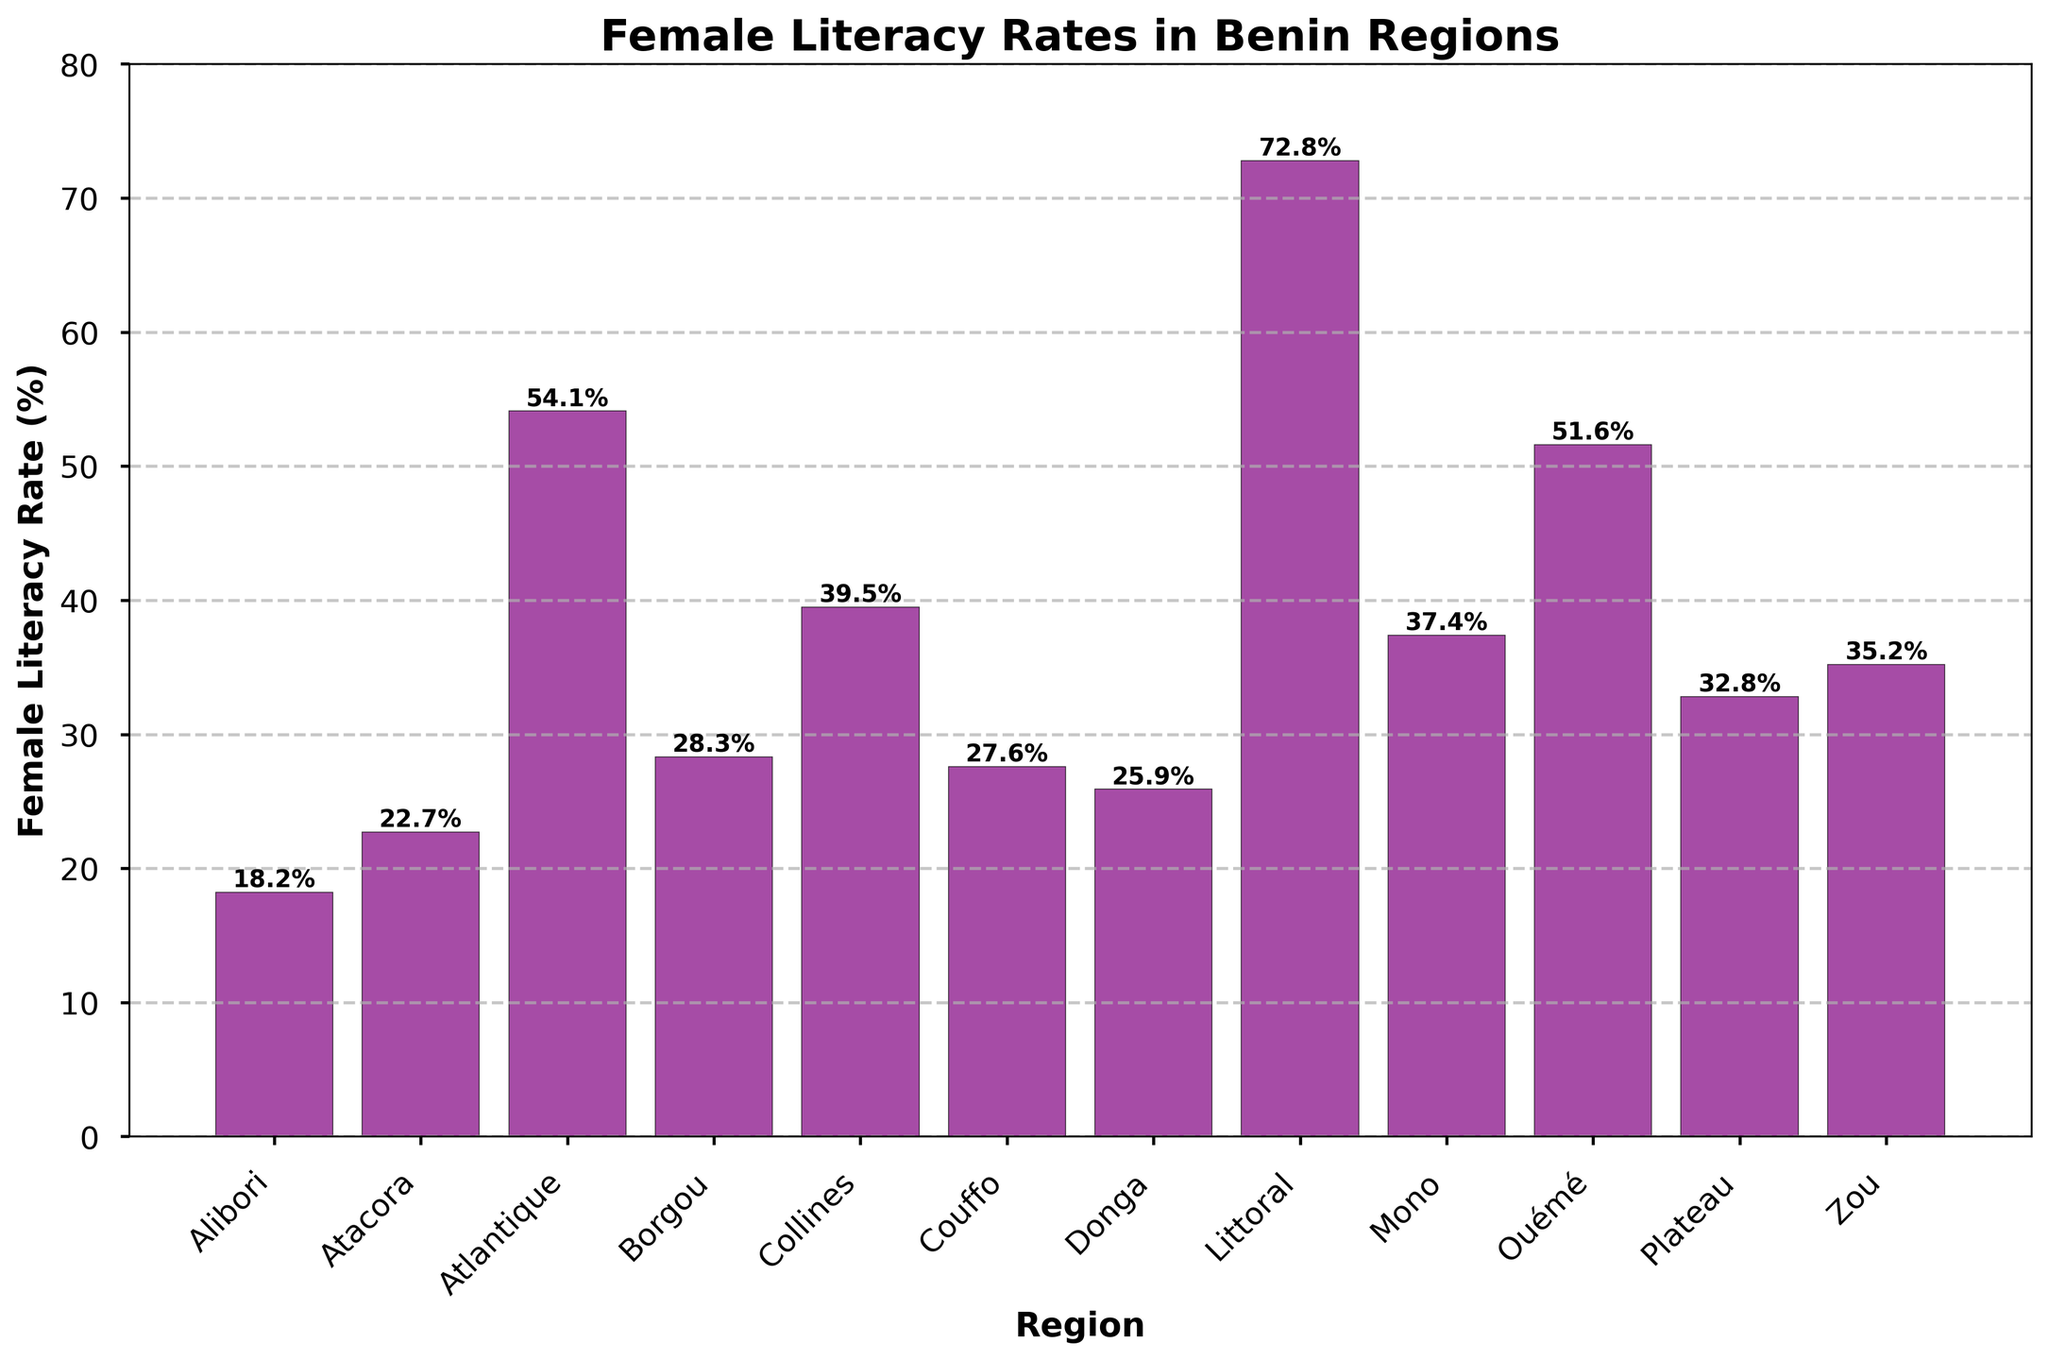Which region has the highest female literacy rate? The highest bar represents the region with the highest female literacy rate. The tallest bar is for Littoral, standing at 72.8%.
Answer: Littoral Which region has the lowest female literacy rate? The lowest bar represents the region with the lowest female literacy rate. The shortest bar is for Alibori, standing at 18.2%.
Answer: Alibori By how much does the female literacy rate in Littoral exceed that in Alibori? Subtract the female literacy rate in Alibori from that in Littoral: 72.8% - 18.2% = 54.6%.
Answer: 54.6% Which regions have a female literacy rate above 50%? Identify the regions where the bars exceed the 50% mark: Atlantique (54.1%), Littoral (72.8%), and Ouémé (51.6%).
Answer: Atlantique, Littoral, Ouémé What is the average female literacy rate among all the regions? Sum all the literacy rates and divide by the number of regions: (18.2 + 22.7 + 54.1 + 28.3 + 39.5 + 27.6 + 25.9 + 72.8 + 37.4 + 51.6 + 32.8 + 35.2) / 12 = 37.95%.
Answer: 37.95% Compare the female literacy rates of Borgou and Collines. Which one is higher and by how much? Borgou has a rate of 28.3%, and Collines has a rate of 39.5%. Subtract Borgou's rate from Collines' rate: 39.5% - 28.3% = 11.2%.
Answer: Collines, by 11.2% Which region has the closest female literacy rate to the average rate? With the calculated average of 37.95%, the region's rate closest to this is Mono with 37.4%.
Answer: Mono What is the combined female literacy rate of the two regions with the highest rates? Identify the two regions with the highest rates, Littoral (72.8%) and Atlantique (54.1%), then add them together: 72.8% + 54.1% = 126.9%.
Answer: 126.9% How does the female literacy rate in Mono compare to that in Zou? Mono's rate is 37.4%, and Zou's rate is 35.2%. Subtract Zou's rate from Mono's rate: 37.4% - 35.2% = 2.2%.
Answer: Mono, by 2.2% 